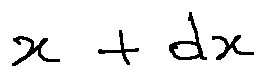Convert formula to latex. <formula><loc_0><loc_0><loc_500><loc_500>x + d x</formula> 